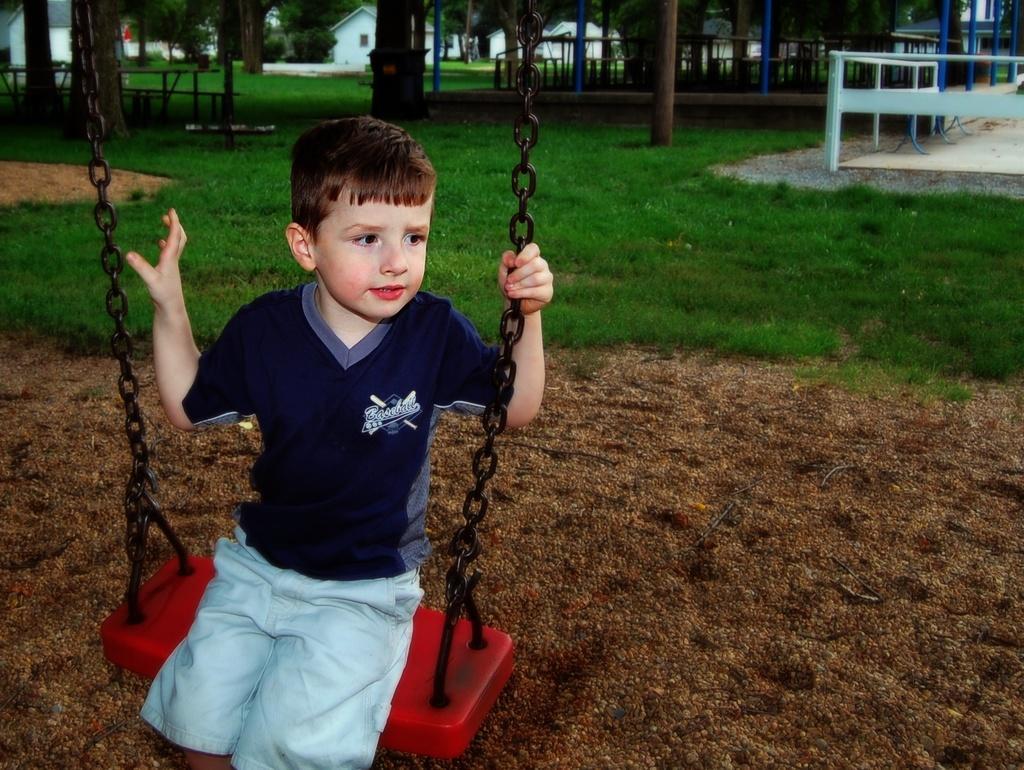Describe this image in one or two sentences. In this image a boy is sitting on a swing. In the background there are trees, benches, boundary and buildings. 